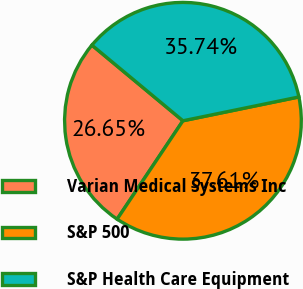Convert chart. <chart><loc_0><loc_0><loc_500><loc_500><pie_chart><fcel>Varian Medical Systems Inc<fcel>S&P 500<fcel>S&P Health Care Equipment<nl><fcel>26.65%<fcel>37.61%<fcel>35.74%<nl></chart> 